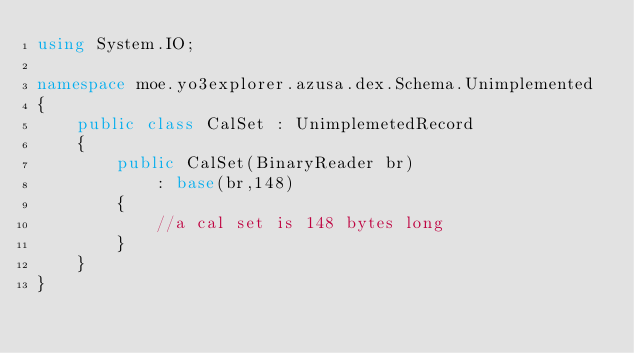Convert code to text. <code><loc_0><loc_0><loc_500><loc_500><_C#_>using System.IO;

namespace moe.yo3explorer.azusa.dex.Schema.Unimplemented
{
    public class CalSet : UnimplemetedRecord
    {
        public CalSet(BinaryReader br)
            : base(br,148)
        {
            //a cal set is 148 bytes long
        }
    }
}</code> 